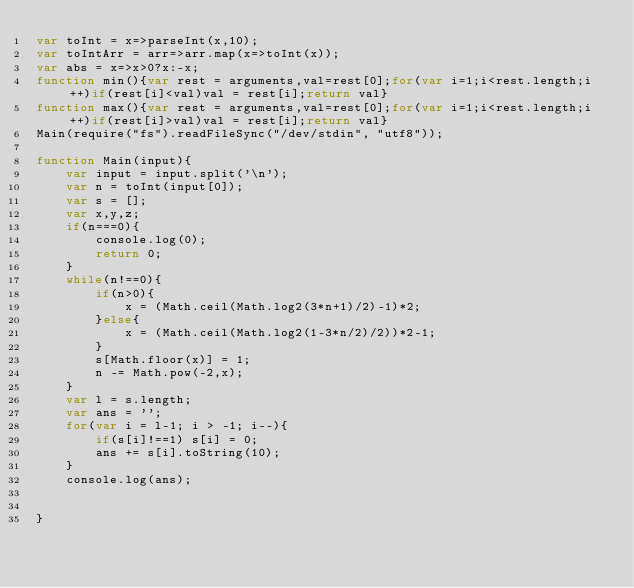Convert code to text. <code><loc_0><loc_0><loc_500><loc_500><_JavaScript_>var toInt = x=>parseInt(x,10);
var toIntArr = arr=>arr.map(x=>toInt(x));
var abs = x=>x>0?x:-x;
function min(){var rest = arguments,val=rest[0];for(var i=1;i<rest.length;i++)if(rest[i]<val)val = rest[i];return val}
function max(){var rest = arguments,val=rest[0];for(var i=1;i<rest.length;i++)if(rest[i]>val)val = rest[i];return val}
Main(require("fs").readFileSync("/dev/stdin", "utf8"));
 
function Main(input){
	var input = input.split('\n');
	var n = toInt(input[0]);
	var s = [];
	var x,y,z;
	if(n===0){
		console.log(0);
		return 0;
	}
	while(n!==0){
		if(n>0){
			x = (Math.ceil(Math.log2(3*n+1)/2)-1)*2;
		}else{
			x = (Math.ceil(Math.log2(1-3*n/2)/2))*2-1;
		}
		s[Math.floor(x)] = 1;
		n -= Math.pow(-2,x);
	}
	var l = s.length;
	var ans = '';
	for(var i = l-1; i > -1; i--){
		if(s[i]!==1) s[i] = 0;
		ans += s[i].toString(10);
	}
	console.log(ans);
	

}</code> 